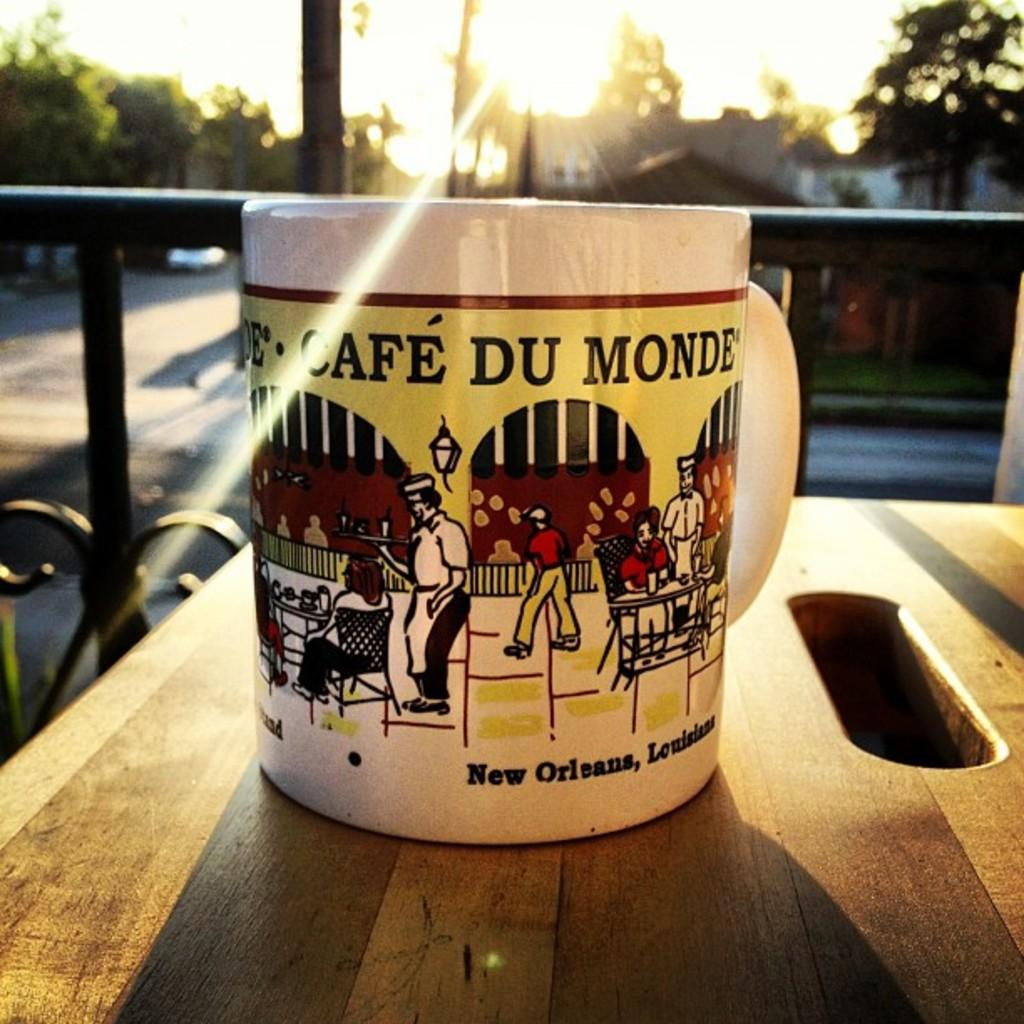<image>
Render a clear and concise summary of the photo. A mug from Cafe Du Monde in New Orleans is on a wooden table. 